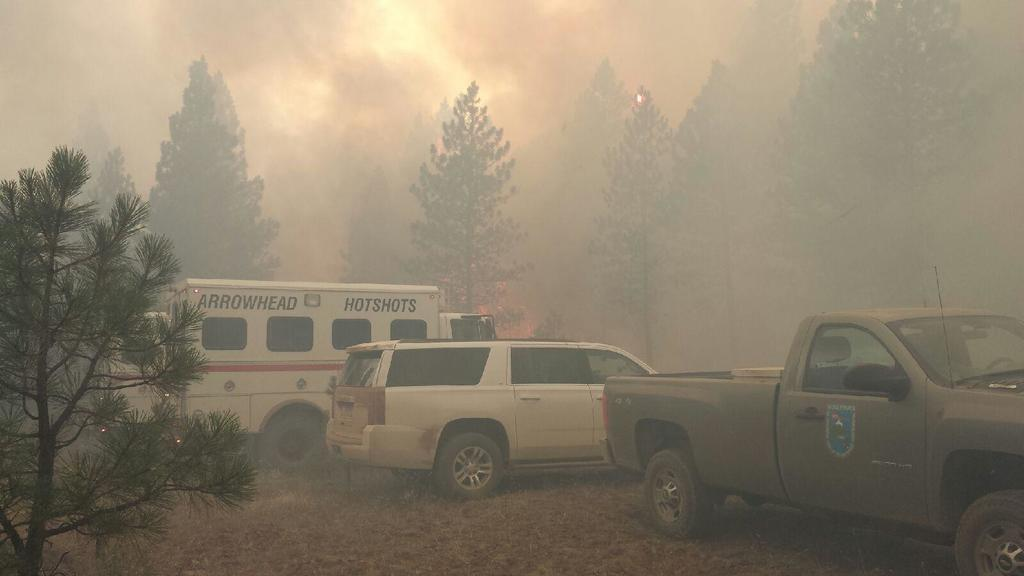What is the overall appearance of the image? The image appears smoky. What can be seen in the foreground of the image? There are trees and vehicles in the foreground of the image, along with dry leaves. What is present in both the foreground and background of the image? Trees are present in both the foreground and background of the image. How would you describe the sky in the image? The sky is cloudy in the image. What type of chalk is being used to draw on the trees in the image? There is no chalk or drawing activity present in the image; it features trees, vehicles, and dry leaves in a smoky environment. Can you confirm the agreement between the trees and vehicles in the image? There is no agreement or interaction between the trees and vehicles in the image; they are simply present in the foreground. 